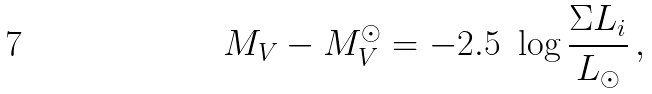Convert formula to latex. <formula><loc_0><loc_0><loc_500><loc_500>M _ { V } - M _ { V } ^ { \odot } = - 2 . 5 \ \log \frac { \Sigma L _ { i } } { L _ { \odot } } \, ,</formula> 